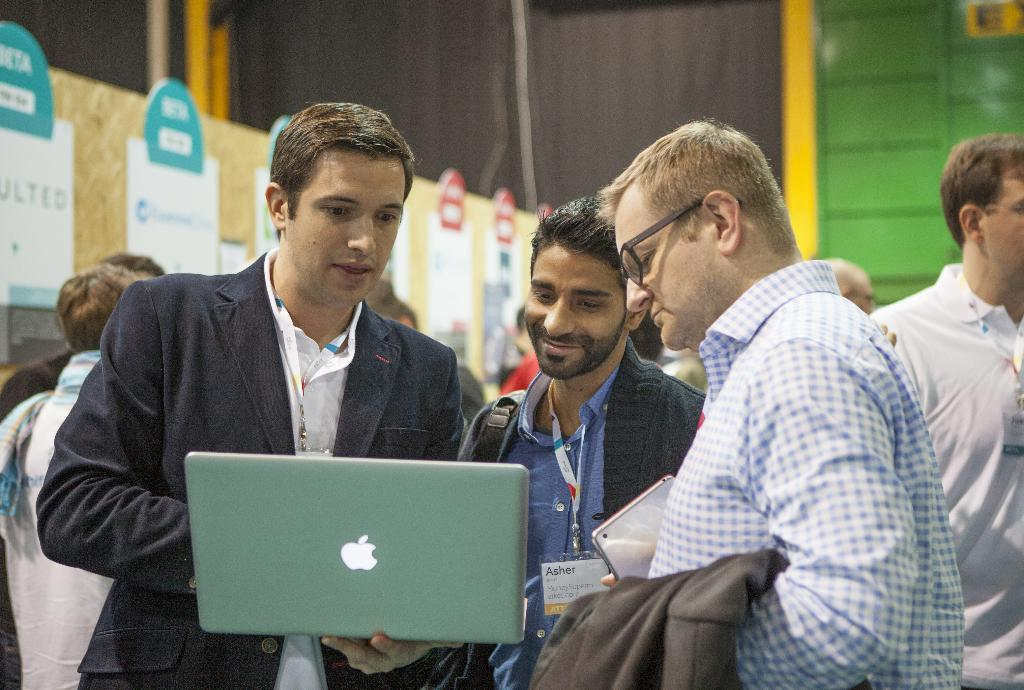How many people are in the image? There is a group of persons in the image. What are some of the persons doing in the foreground? Some persons are holding objects in the foreground. What can be seen in the background of the image? There is a wall in the background of the image. What is on the wall in the background? There are banners on the wall. Can you tell me how many deer are visible in the image? There are no deer present in the image. What decision was made by the group of persons in the image? The provided facts do not mention any decisions made by the group of persons in the image. --- Facts: 1. There is a person sitting on a chair in the image. 2. The person is holding a book. 3. There is a table next to the chair. 4. There is a lamp on the table. Absurd Topics: parrot, ocean, bicycle Conversation: What is the person in the image doing? There is a person sitting on a chair in the image. What is the person holding? The person is holding a book. What is next to the chair? There is a table next to the chair. What is on the table? There is a lamp on the table. Reasoning: Let's think step by step in order to produce the conversation. We start by identifying the main subject in the image, which is the person sitting on a chair. Next, we describe what the person is holding, which is a book. Then, we observe the presence of a table next to the chair. Finally, we describe what is on the table, which is a lamp. Absurd Question/Answer: Can you see a parrot in the image? No, there is no parrot present in the image. 